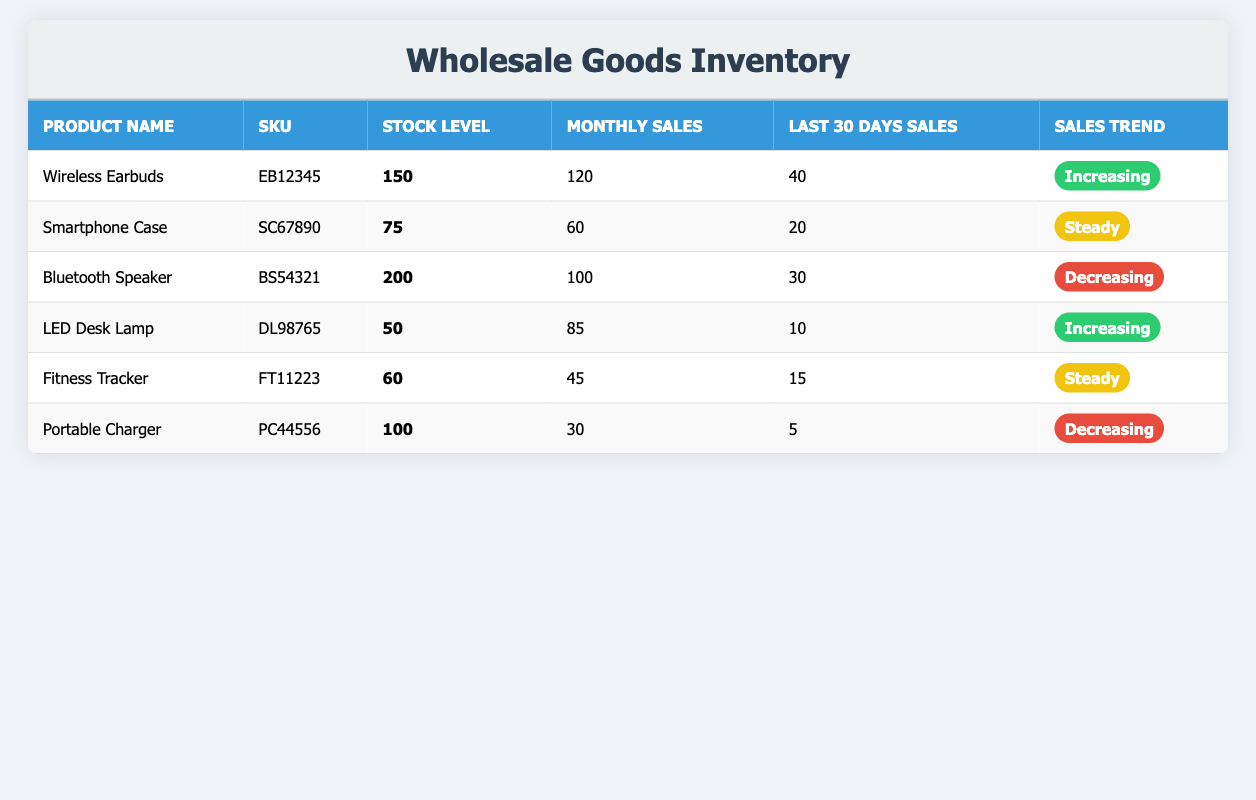What is the stock level of the Wireless Earbuds? The stock level is clearly listed in the table for the Wireless Earbuds product, which shows 150 units available.
Answer: 150 Which product has the highest monthly sales? By comparing the monthly sales figures in the table, the Wireless Earbuds' monthly sales of 120 exceed all others, making it the highest.
Answer: Wireless Earbuds What is the total stock level of products with a steady sales trend? The only products with a steady sales trend are the Smartphone Case and Fitness Tracker, with stock levels of 75 and 60 respectively. Adding these gives 75 + 60 = 135.
Answer: 135 Is the sales trend for the Bluetooth Speaker increasing? The Bluetooth Speaker has a sales trend listed as decreasing in the table. Therefore, the statement is false.
Answer: No How many products have a stock level below 100? The products with stock levels below 100 are the LED Desk Lamp (50), Fitness Tracker (60), and Portable Charger (100, which is not below). Therefore, there are two products: LED Desk Lamp and Fitness Tracker.
Answer: 2 What is the average monthly sales of all products with an increasing sales trend? The products with an increasing sales trend are the Wireless Earbuds (120) and LED Desk Lamp (85). To find the average: (120 + 85) / 2 = 205 / 2 = 102.5.
Answer: 102.5 Do any products have a stock level above 150? Reviewing the table, the Bluetooth Speaker has a stock level of 200, which is above 150. Therefore, at least one product meets this criterion.
Answer: Yes How many total units of stock are there across all products? Adding the stock levels of all products gives: 150 + 75 + 200 + 50 + 60 + 100 = 635.
Answer: 635 